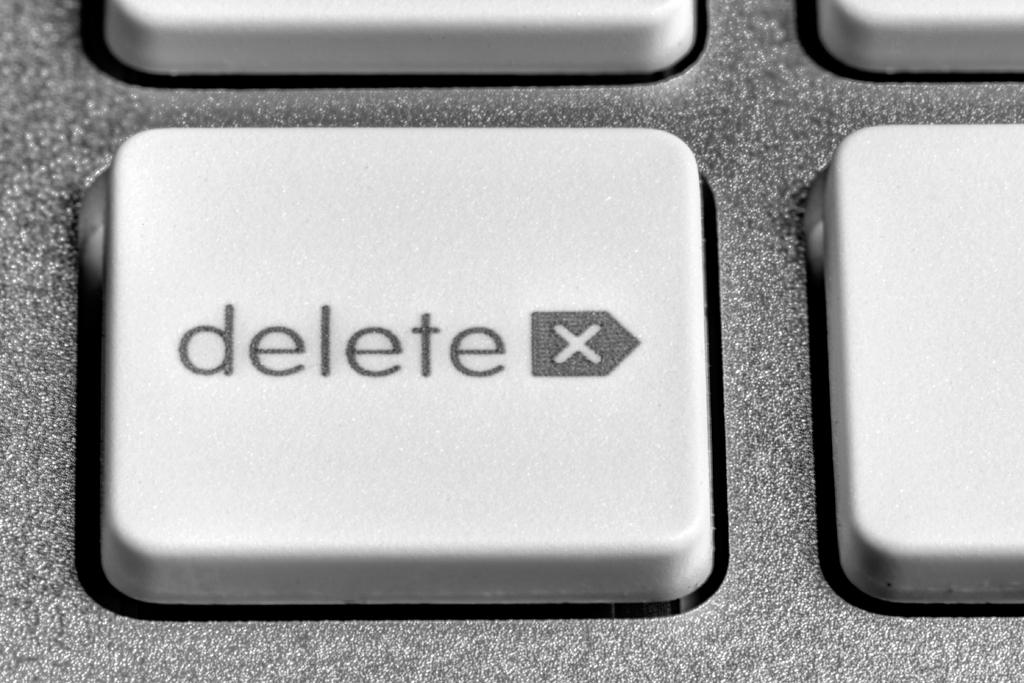<image>
Create a compact narrative representing the image presented. The delete key on a keyboard  up close. 